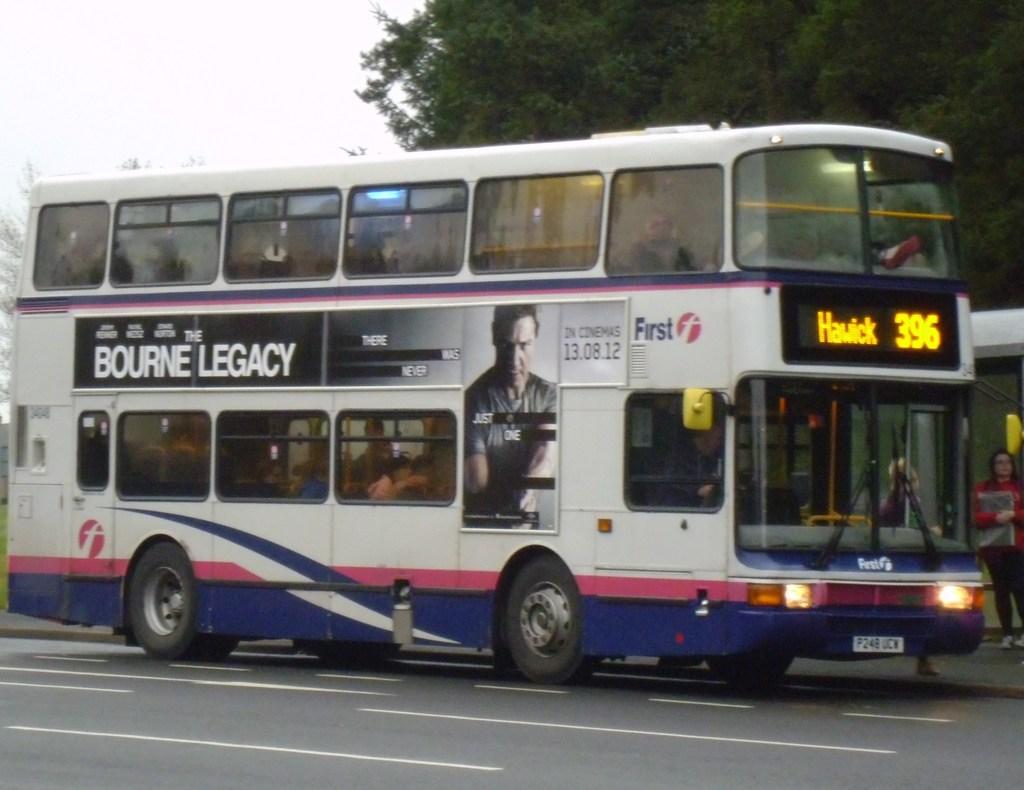What movie is advertised here?
Ensure brevity in your answer.  Bourne legacy. 